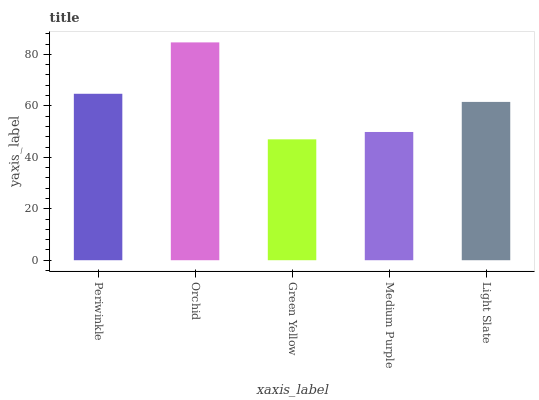Is Green Yellow the minimum?
Answer yes or no. Yes. Is Orchid the maximum?
Answer yes or no. Yes. Is Orchid the minimum?
Answer yes or no. No. Is Green Yellow the maximum?
Answer yes or no. No. Is Orchid greater than Green Yellow?
Answer yes or no. Yes. Is Green Yellow less than Orchid?
Answer yes or no. Yes. Is Green Yellow greater than Orchid?
Answer yes or no. No. Is Orchid less than Green Yellow?
Answer yes or no. No. Is Light Slate the high median?
Answer yes or no. Yes. Is Light Slate the low median?
Answer yes or no. Yes. Is Green Yellow the high median?
Answer yes or no. No. Is Periwinkle the low median?
Answer yes or no. No. 